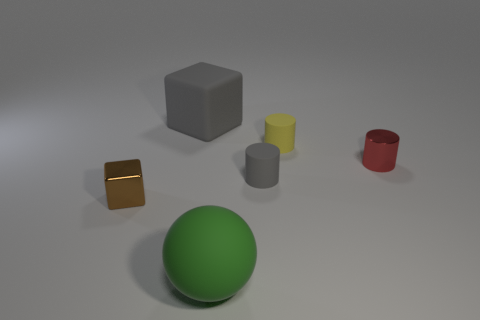Add 1 small green things. How many objects exist? 7 Subtract all cubes. How many objects are left? 4 Subtract 1 yellow cylinders. How many objects are left? 5 Subtract all yellow rubber cylinders. Subtract all shiny objects. How many objects are left? 3 Add 2 tiny rubber things. How many tiny rubber things are left? 4 Add 6 big cyan spheres. How many big cyan spheres exist? 6 